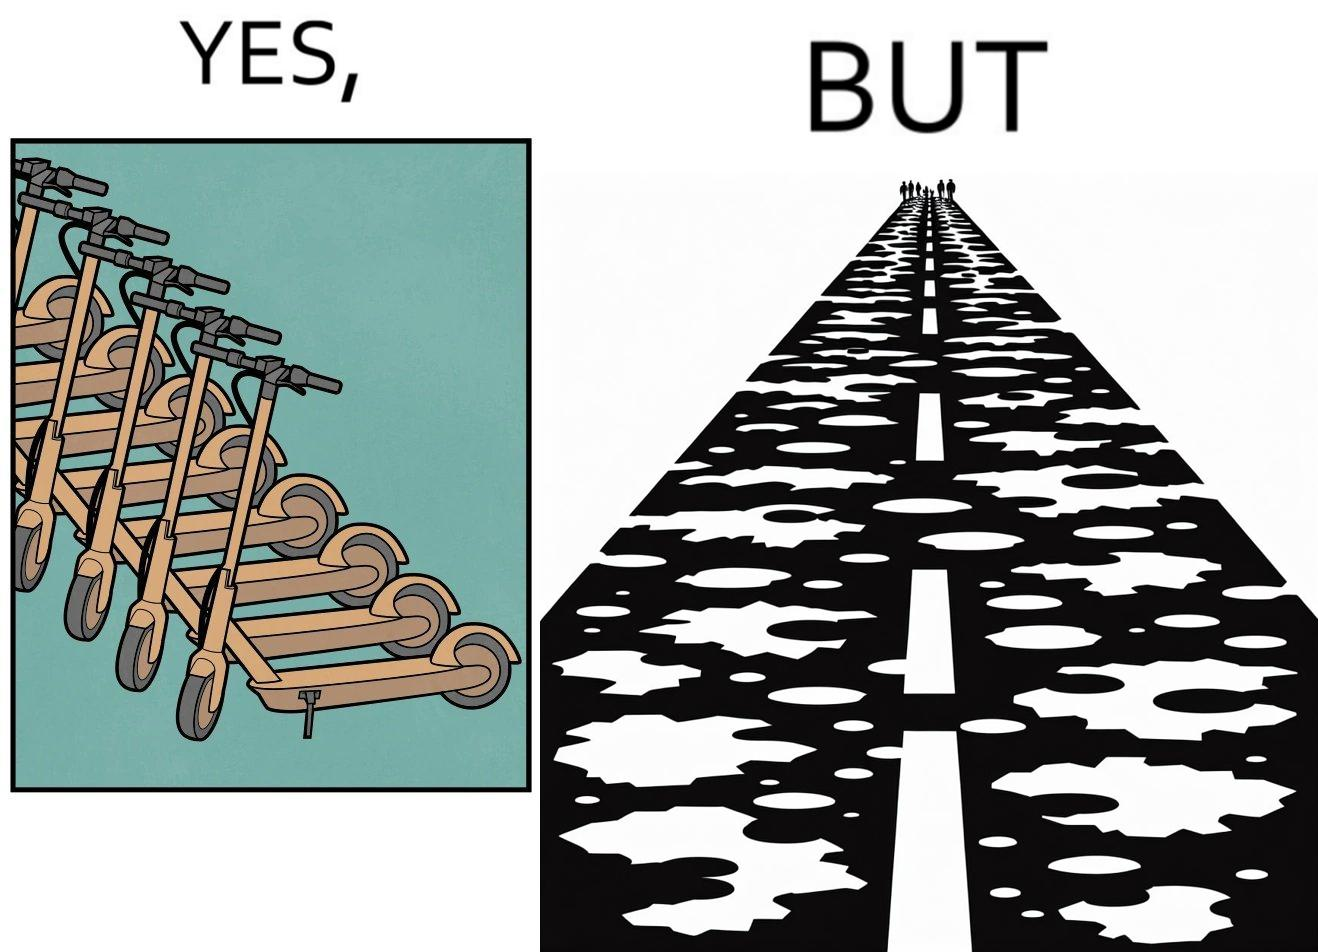Describe what you see in the left and right parts of this image. In the left part of the image: many skateboard scooters parked together In the right part of the image: a straight road with many potholes 